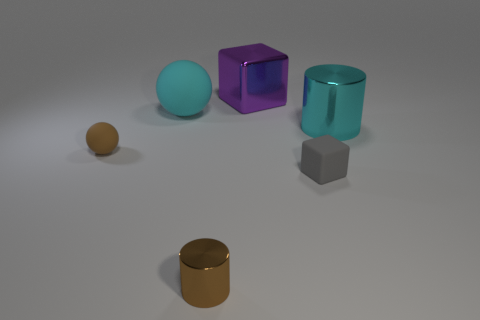There is a cyan object right of the cyan object behind the cyan metallic object to the right of the tiny gray thing; how big is it?
Offer a very short reply. Large. There is a big cylinder; how many brown spheres are behind it?
Provide a short and direct response. 0. Are there more large purple things than green shiny things?
Offer a terse response. Yes. There is a thing that is the same color as the small rubber sphere; what size is it?
Your response must be concise. Small. There is a object that is on the left side of the big cyan cylinder and on the right side of the big purple cube; what is its size?
Offer a very short reply. Small. There is a cube behind the small brown matte object in front of the metallic cylinder to the right of the tiny matte block; what is its material?
Your answer should be compact. Metal. What is the material of the big thing that is the same color as the big sphere?
Give a very brief answer. Metal. Does the metallic thing right of the purple shiny thing have the same color as the big thing on the left side of the purple thing?
Your response must be concise. Yes. The tiny object behind the tiny rubber object in front of the small sphere that is in front of the large purple shiny object is what shape?
Your answer should be compact. Sphere. There is a large object that is both on the right side of the large cyan rubber object and to the left of the big cylinder; what is its shape?
Provide a succinct answer. Cube. 